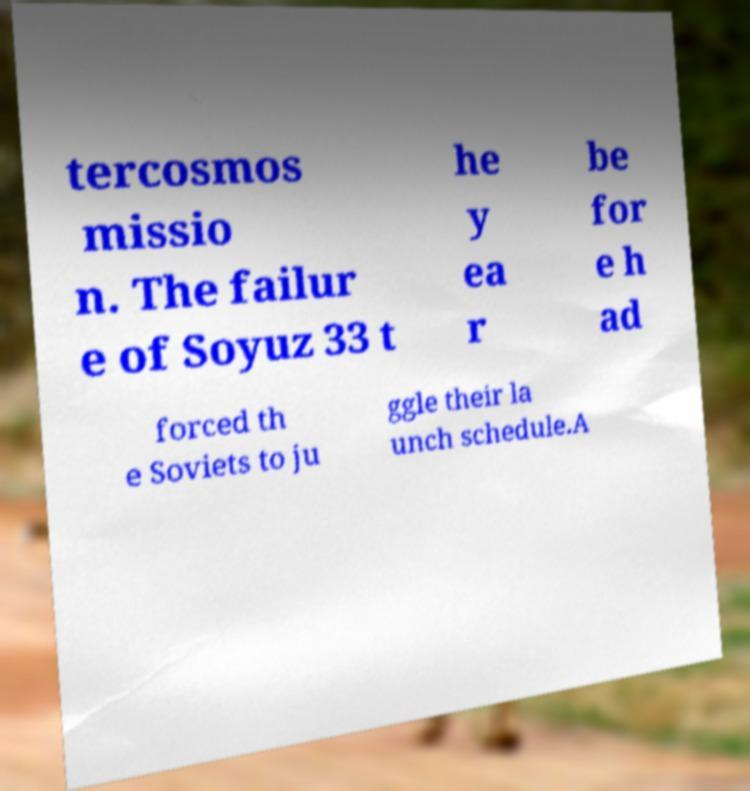I need the written content from this picture converted into text. Can you do that? tercosmos missio n. The failur e of Soyuz 33 t he y ea r be for e h ad forced th e Soviets to ju ggle their la unch schedule.A 